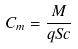Convert formula to latex. <formula><loc_0><loc_0><loc_500><loc_500>C _ { m } = \frac { M } { q S c }</formula> 